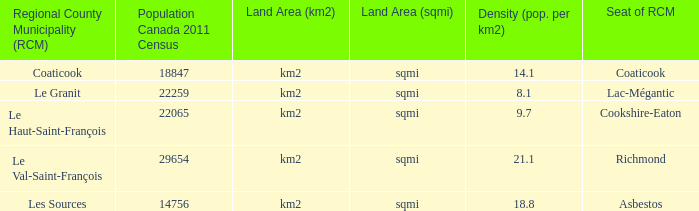7? Le Haut-Saint-François. 